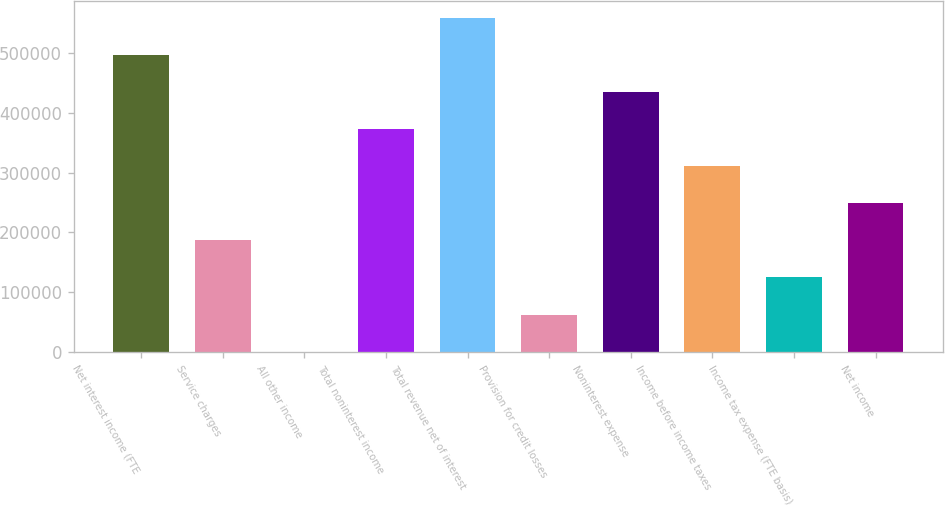Convert chart to OTSL. <chart><loc_0><loc_0><loc_500><loc_500><bar_chart><fcel>Net interest income (FTE<fcel>Service charges<fcel>All other income<fcel>Total noninterest income<fcel>Total revenue net of interest<fcel>Provision for credit losses<fcel>Noninterest expense<fcel>Income before income taxes<fcel>Income tax expense (FTE basis)<fcel>Net income<nl><fcel>496299<fcel>186566<fcel>727<fcel>372406<fcel>558246<fcel>62673.5<fcel>434352<fcel>310460<fcel>124620<fcel>248513<nl></chart> 